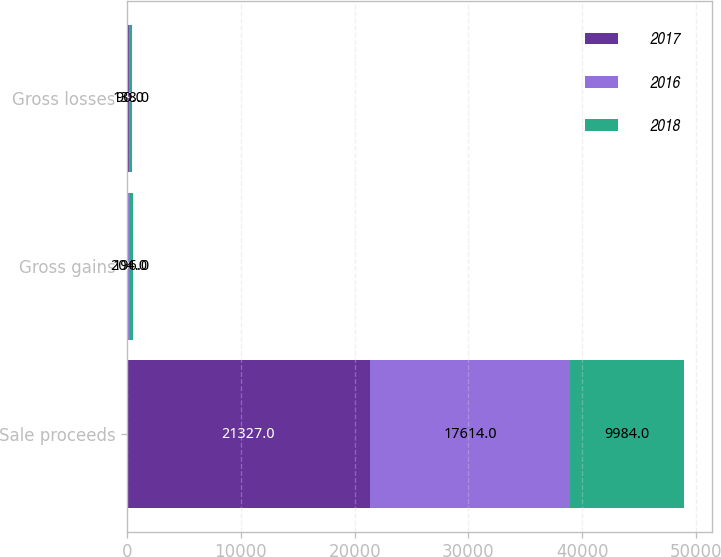Convert chart. <chart><loc_0><loc_0><loc_500><loc_500><stacked_bar_chart><ecel><fcel>Sale proceeds<fcel>Gross gains<fcel>Gross losses<nl><fcel>2017<fcel>21327<fcel>90<fcel>169<nl><fcel>2016<fcel>17614<fcel>204<fcel>90<nl><fcel>2018<fcel>9984<fcel>196<fcel>138<nl></chart> 